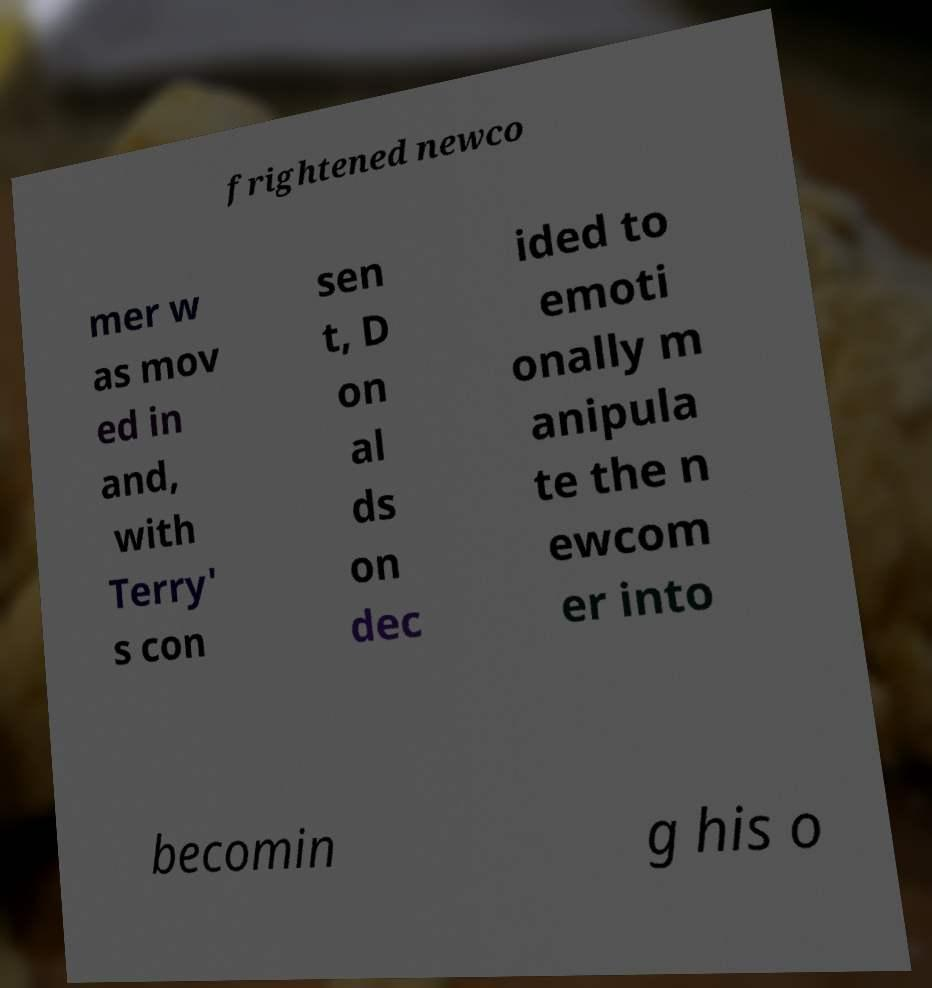Please identify and transcribe the text found in this image. frightened newco mer w as mov ed in and, with Terry' s con sen t, D on al ds on dec ided to emoti onally m anipula te the n ewcom er into becomin g his o 